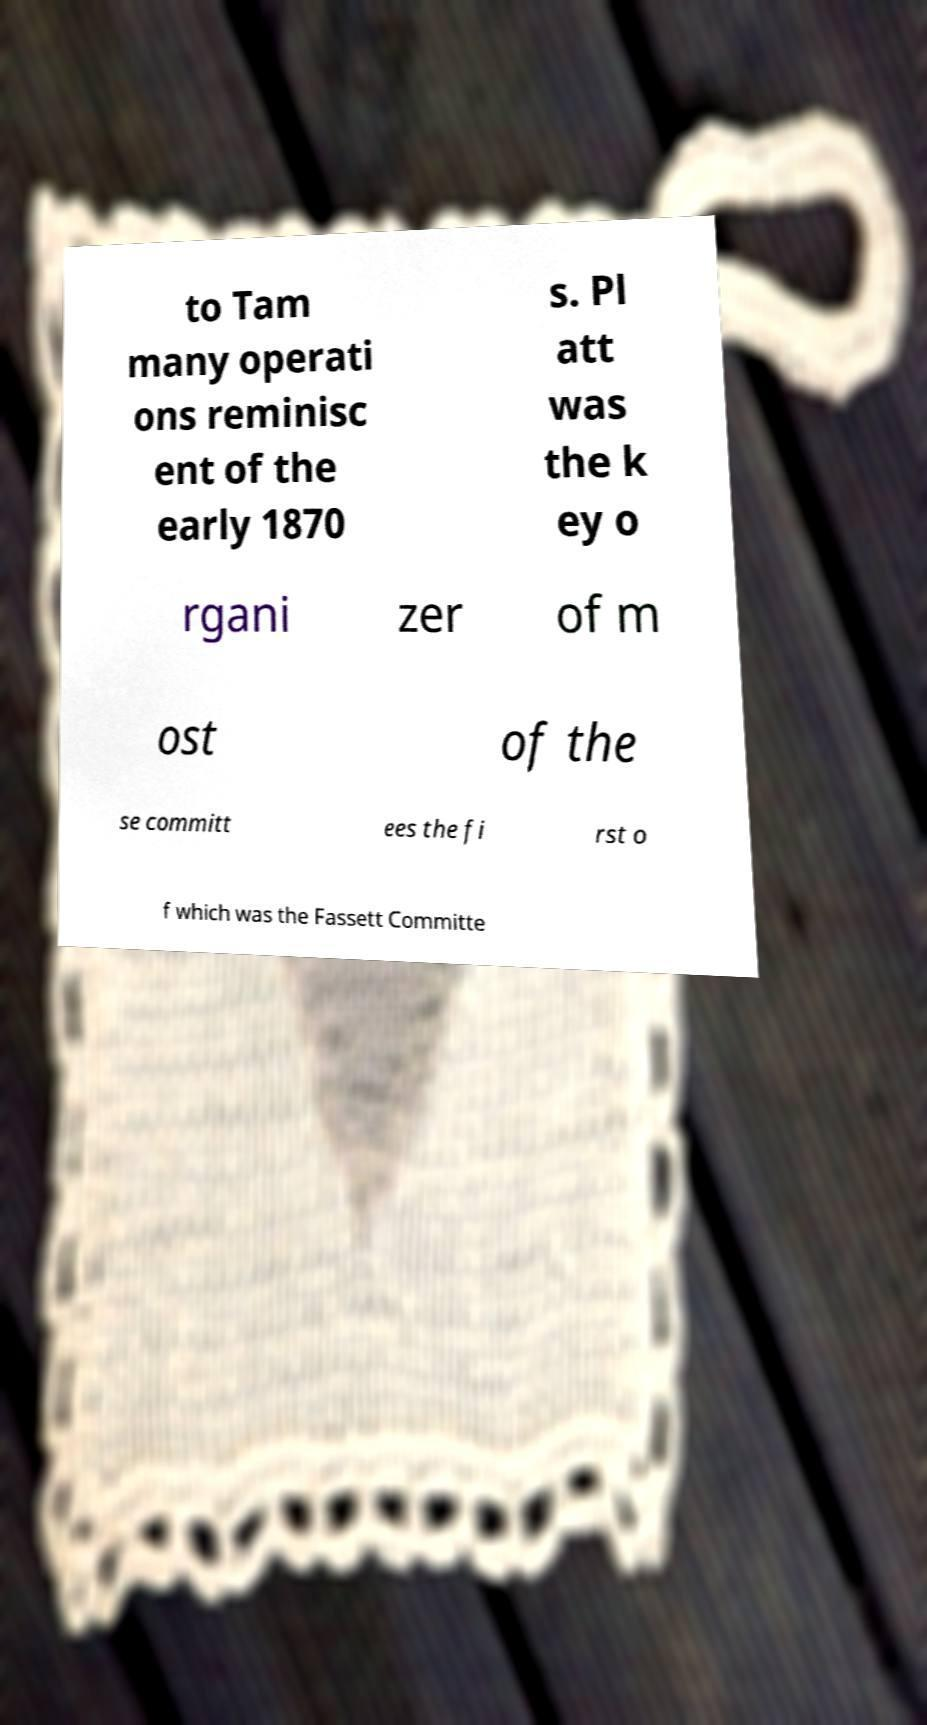Please identify and transcribe the text found in this image. to Tam many operati ons reminisc ent of the early 1870 s. Pl att was the k ey o rgani zer of m ost of the se committ ees the fi rst o f which was the Fassett Committe 